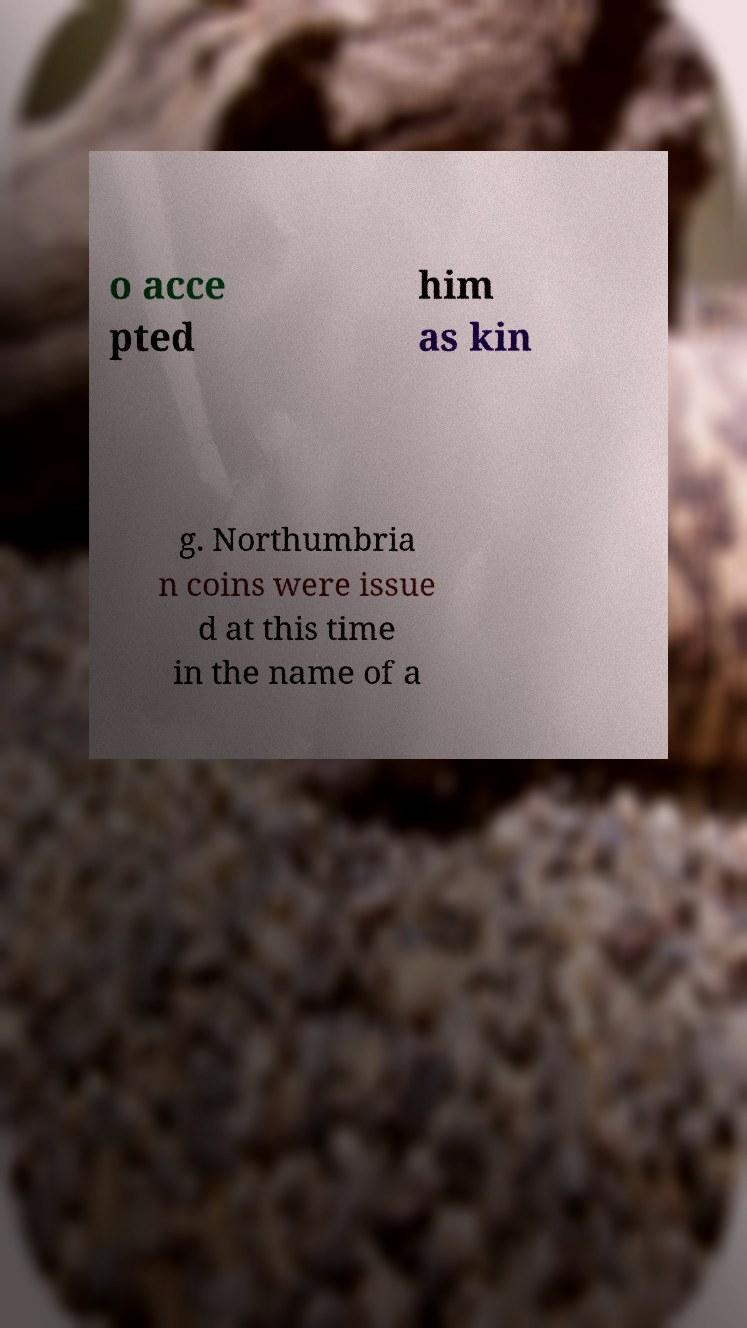Please read and relay the text visible in this image. What does it say? o acce pted him as kin g. Northumbria n coins were issue d at this time in the name of a 